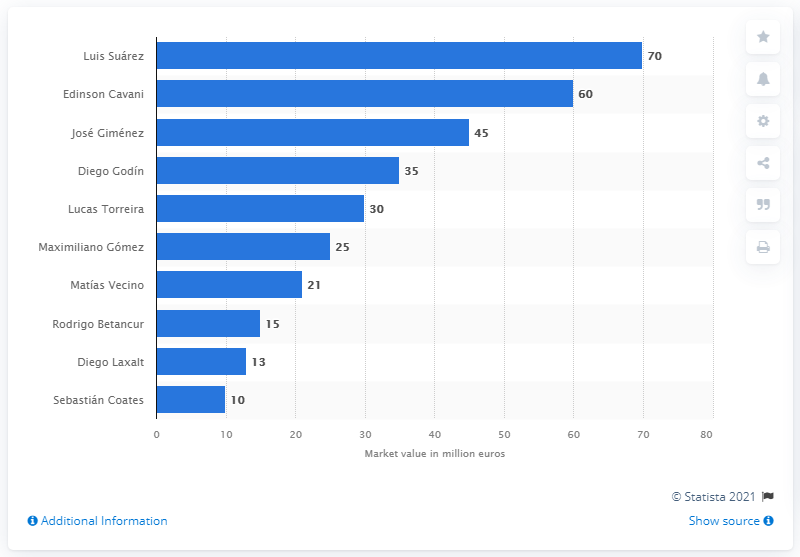Outline some significant characteristics in this image. The second most valuable Uruguayan soccer player is Edinson Cavani. 